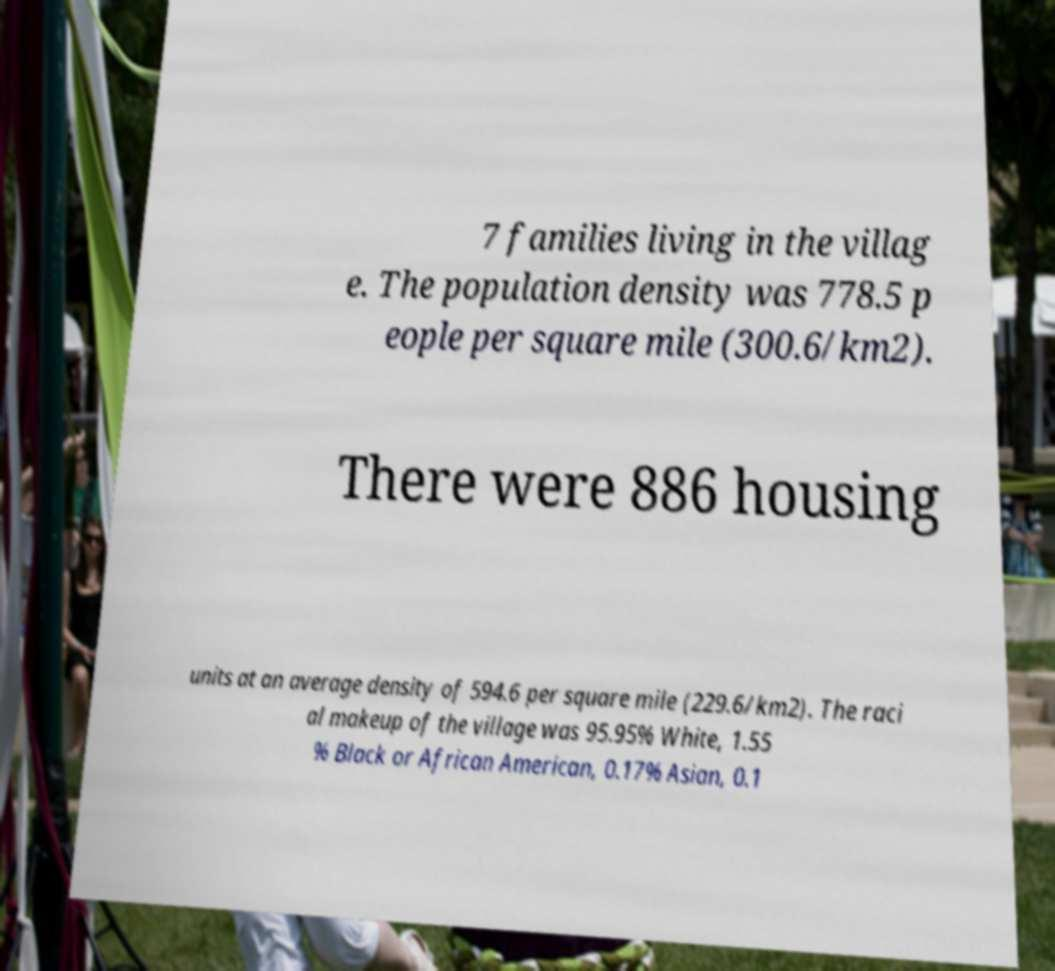Could you assist in decoding the text presented in this image and type it out clearly? 7 families living in the villag e. The population density was 778.5 p eople per square mile (300.6/km2). There were 886 housing units at an average density of 594.6 per square mile (229.6/km2). The raci al makeup of the village was 95.95% White, 1.55 % Black or African American, 0.17% Asian, 0.1 